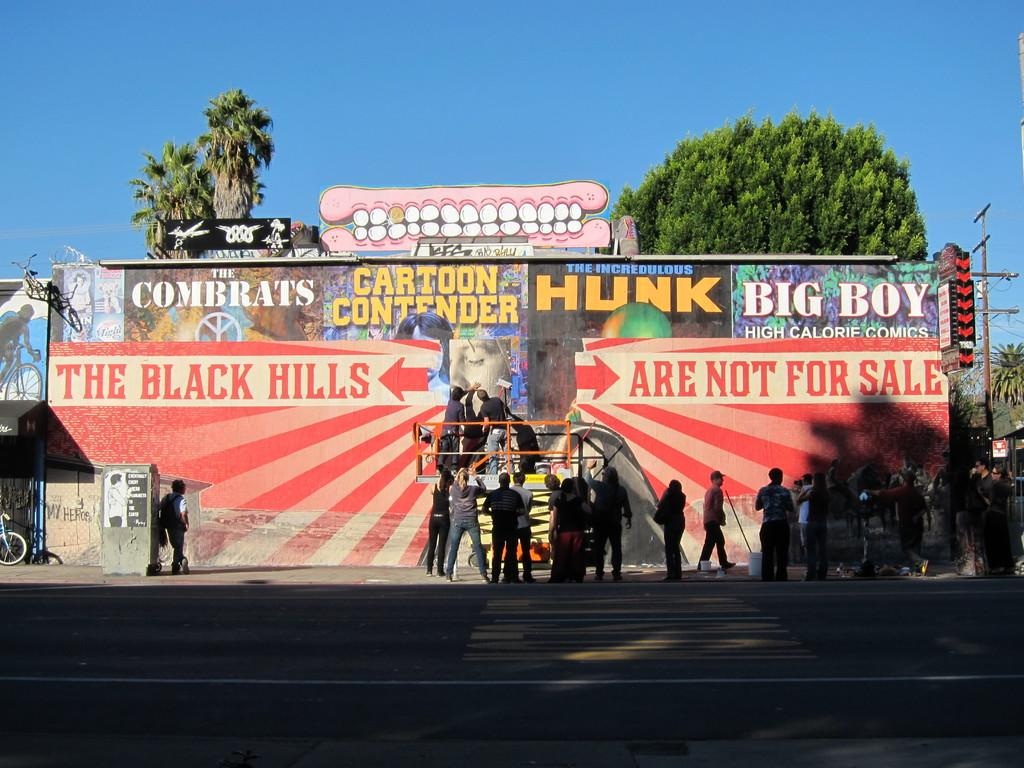How many individuals are present in the image? There are many people in the image. What is the location of the people in the image? The people are standing before a wall. What can be observed on the wall in the image? The wall has graffiti on it. What can be seen in the distance behind the people and the wall? There are trees visible in the background of the image. What type of box is being used to condition the stem in the image? There is no box or stem present in the image; it features a group of people standing before a wall with graffiti. 